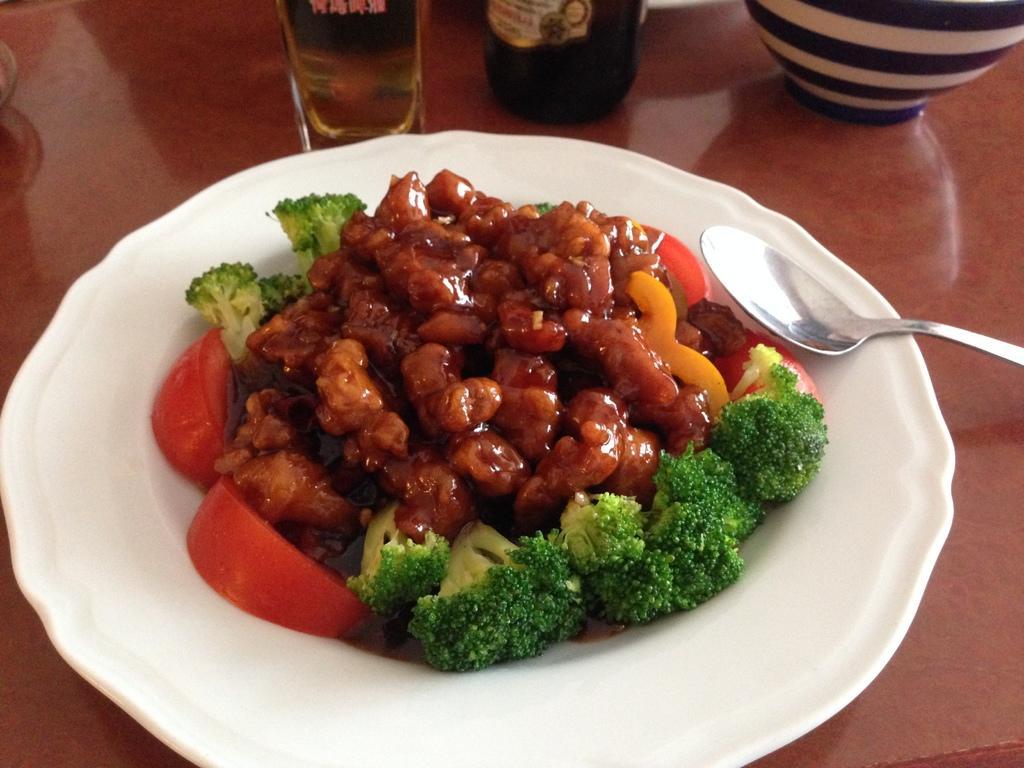Can you describe this image briefly? In this image there is a plate on which there is some food like broccoli leaves,tomato pieces,capsicum,sauce on it. Beside the plate there are glass bottles. On the right side there is a spoon in the plate. On the right side top there is a bowl. The plate is on the table. 